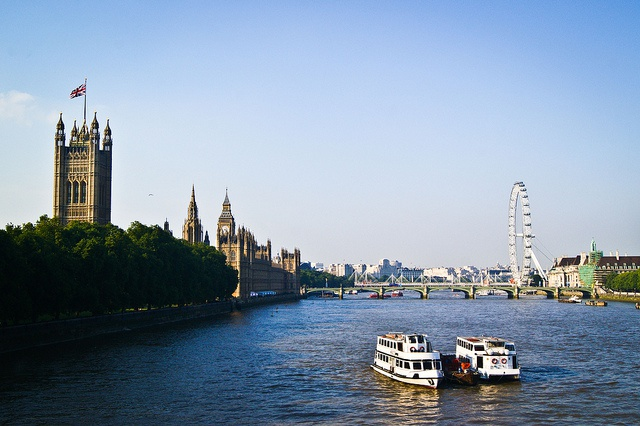Describe the objects in this image and their specific colors. I can see boat in lightblue, white, black, gray, and darkgray tones, boat in lightblue, white, black, darkgray, and gray tones, boat in lightblue, black, maroon, navy, and gray tones, boat in lightblue, black, gray, tan, and olive tones, and boat in lightblue, ivory, black, tan, and darkgray tones in this image. 